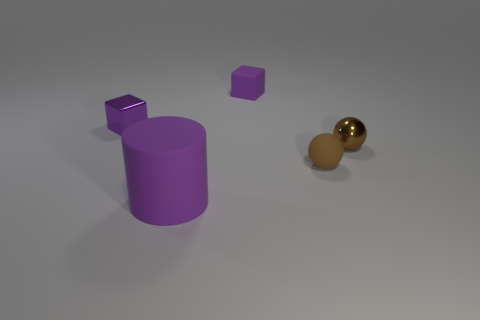Add 5 big cyan shiny cubes. How many objects exist? 10 Subtract all cylinders. How many objects are left? 4 Add 3 matte objects. How many matte objects are left? 6 Add 2 red matte spheres. How many red matte spheres exist? 2 Subtract 0 green cylinders. How many objects are left? 5 Subtract all purple metallic cubes. Subtract all rubber balls. How many objects are left? 3 